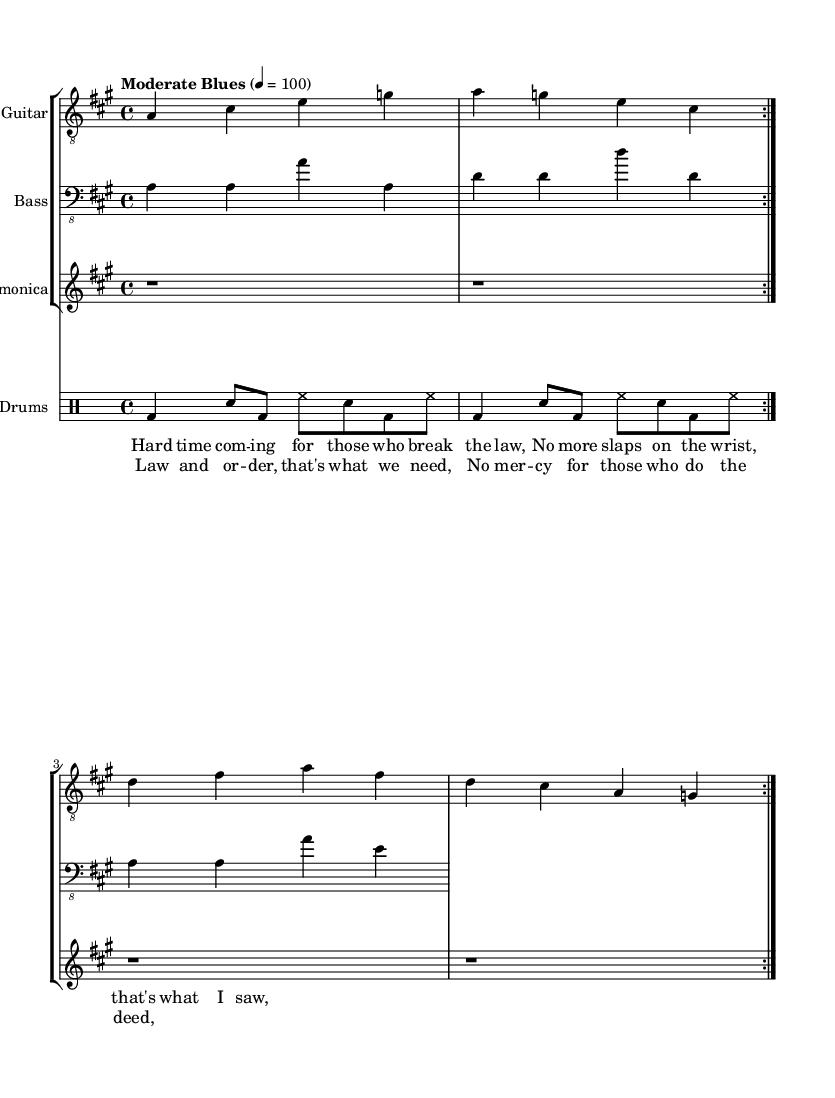What is the key signature of this music? The key signature shown in the sheet music is A major, which has three sharps (F#, C#, and G#). You can identify this by looking at the key signature indication, which is typically located at the beginning of the staff.
Answer: A major What is the time signature of this piece? The time signature is 4/4, indicated at the beginning of the score. This can be noted by the fraction-like symbol showing four beats per measure, with a quarter note receiving one beat.
Answer: 4/4 What is the tempo marking for this music? The tempo marking reads "Moderate Blues" with a metronome marking of 100 beats per minute. This information is usually at the start of the score to guide the performance speed.
Answer: Moderate Blues How many bars are in the verse section? There are four bars in the verse section, as indicated by the four measures shown before the chorus starts. Counting the measures provides the total number of bars.
Answer: 4 What instrument plays the harmonica part? The harmonica part is played by a designated staff labeled "Harmonica," which typically indicates the melodic line for that instrument in the arrangement.
Answer: Harmonica What lyrical theme is emphasized in the chorus? The chorus emphasizes the need for "Law and order," which is stated clearly in the lyrics provided in that section, focusing on a societal demand for justice.
Answer: Law and order How many times is the electric guitar part repeated? The electric guitar part is repeated twice, as indicated by the volta that instructs the player to repeat the section. Repeats are typically noted at the beginning and end of the repeated section.
Answer: 2 